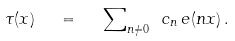Convert formula to latex. <formula><loc_0><loc_0><loc_500><loc_500>\tau ( x ) \ \ = \ \ { \sum } _ { n \neq 0 } \ c _ { n } \, e ( n x ) \, .</formula> 